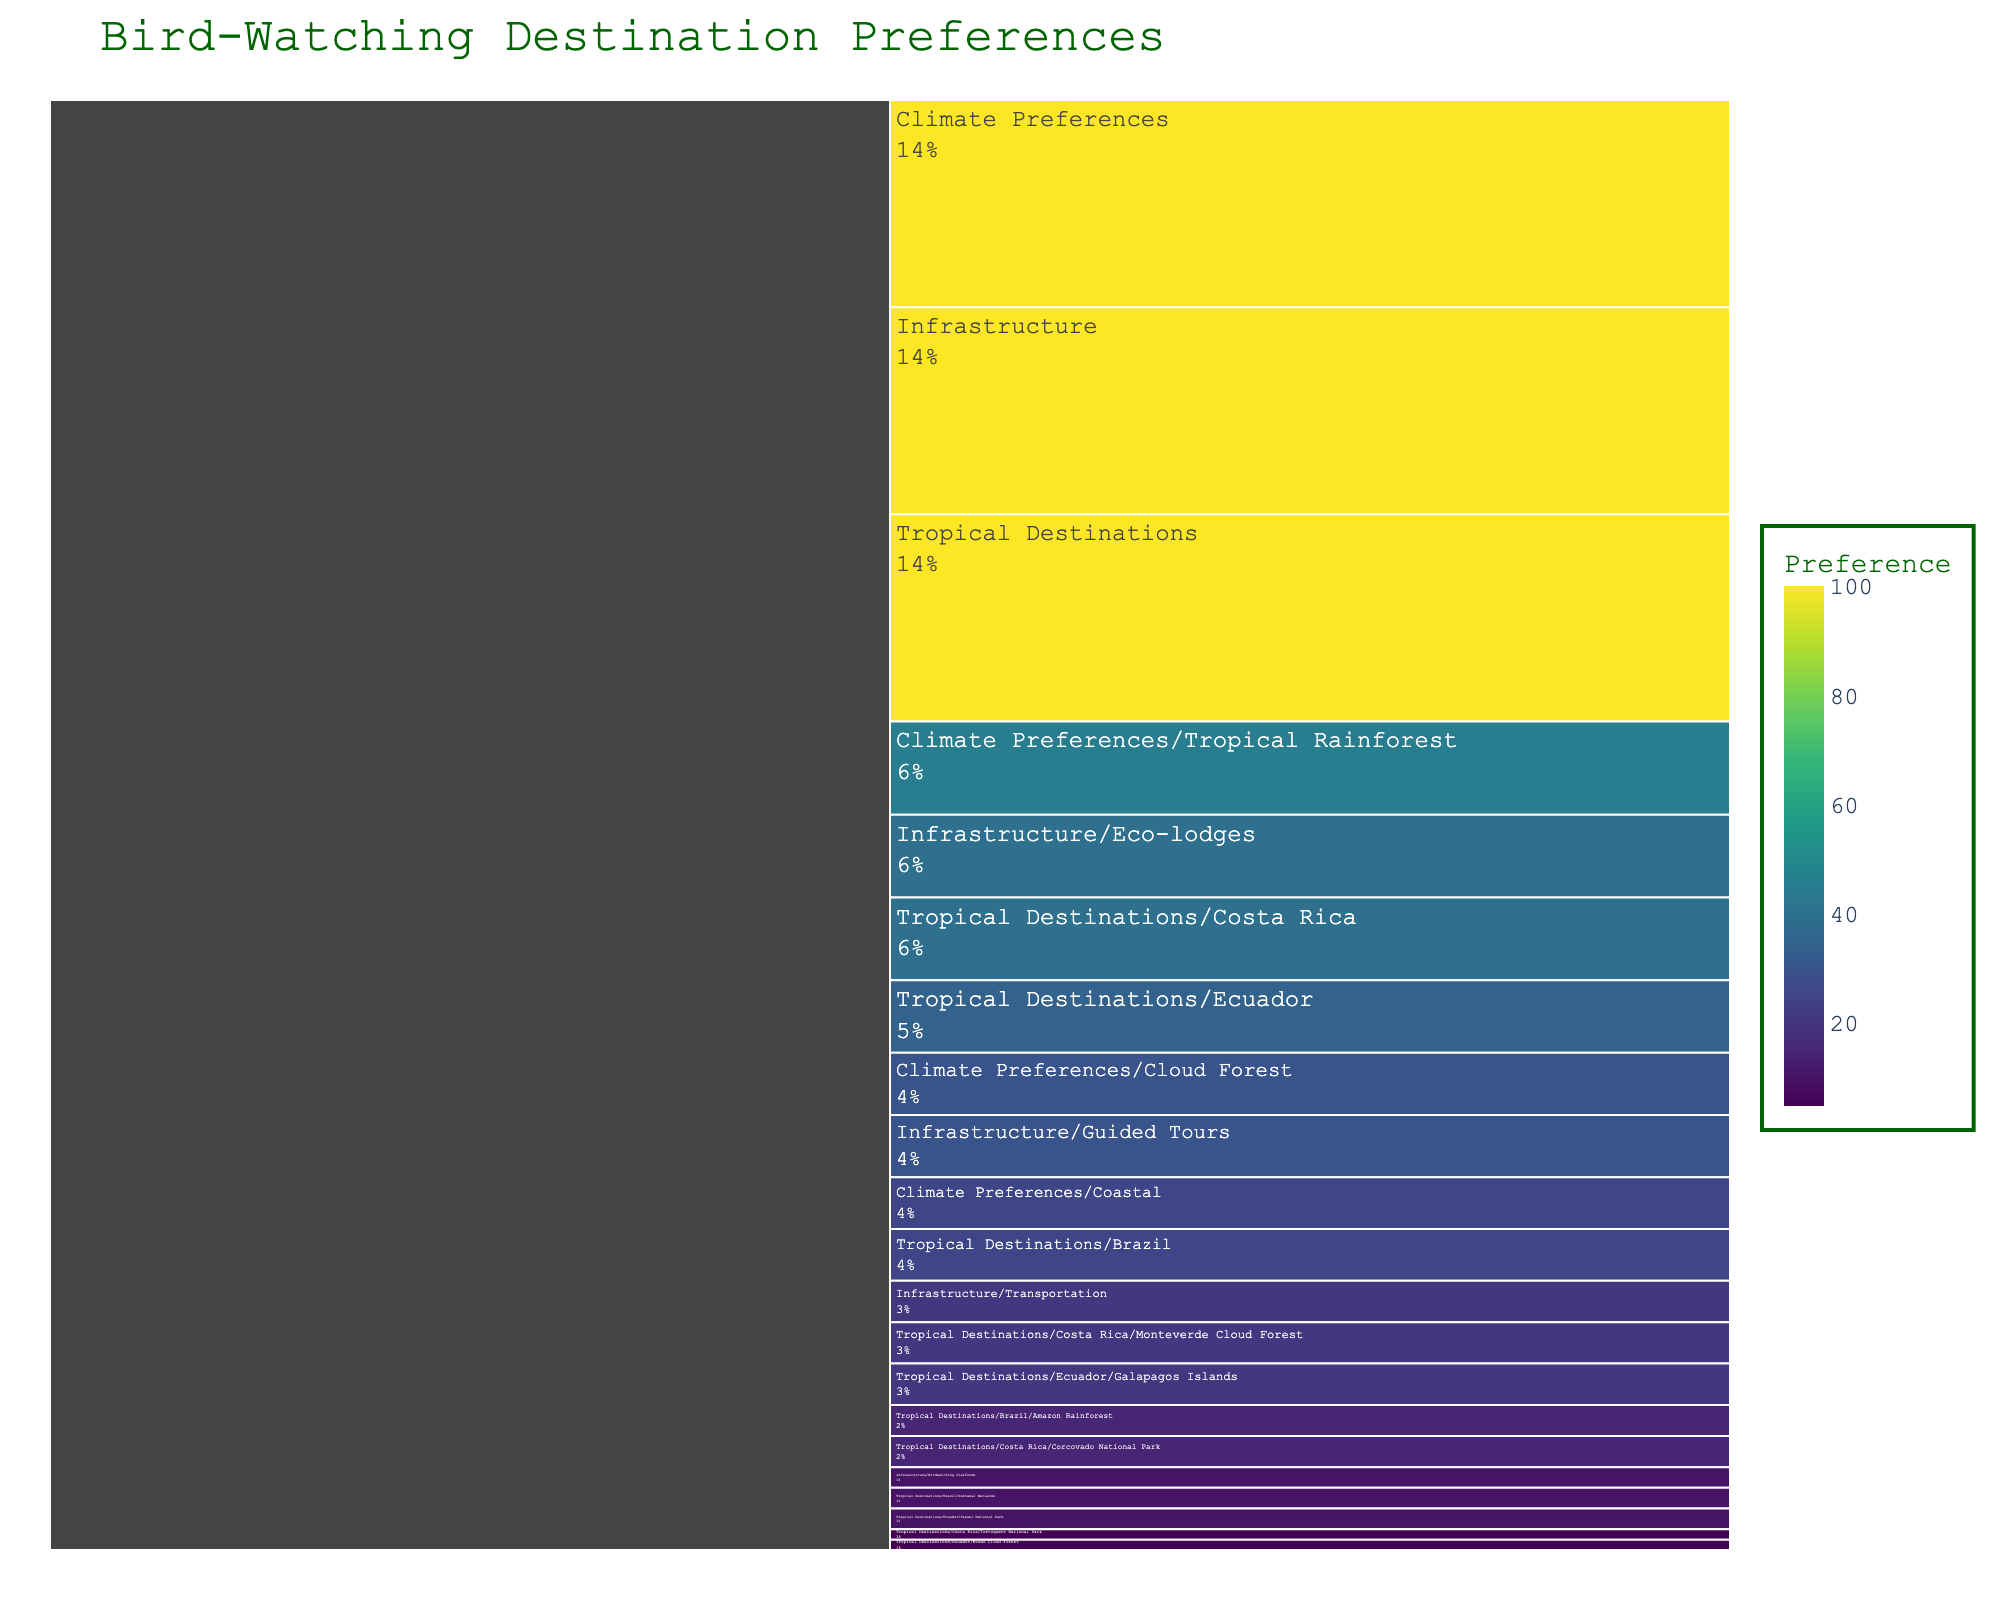What is the total preference percentage for Costa Rica within Tropical Destinations? We look at the preference values for Monteverde Cloud Forest (20), Corcovado National Park (15), and Tortuguero National Park (5). Summing them gives us 20 + 15 + 5 = 40. Therefore, the total preference percentage for Costa Rica is 40%.
Answer: 40% Which subcategory within Ecuador has the highest preference? We examine the subcategories under Ecuador and compare their preference values: Galapagos Islands (20), Yasuni National Park (10), and Mindo Cloud Forest (5). The highest preference is for Galapagos Islands.
Answer: Galapagos Islands How much higher is the preference for Tropical Rainforest compared to Coastal climate? The preference for Tropical Rainforest is 45, and for Coastal it is 25. The difference is 45 - 25 = 20.
Answer: 20 Which type of infrastructure has the lowest preference? We look at the preference values for all infrastructure types: Eco-lodges (40), Guided Tours (30), Transportation (20), and Birdwatching Platforms (10). The lowest preference is for Birdwatching Platforms.
Answer: Birdwatching Platforms What percentage of the total preference is given to the Galapagos Islands? Galapagos Islands have a preference value of 20 out of the total preference considered, which is 100 for Tropical Destinations. Therefore, the percentage is (20/100)*100% = 20%.
Answer: 20% Compare the total preferences for each country within Tropical Destinations. Which country has the highest total preference? Costa Rica (40), Ecuador (35), and Brazil (25). Costa Rica has the highest total preference.
Answer: Costa Rica What is the combined preference for Eco-lodges and Guided Tours? The values are Eco-lodges (40) and Guided Tours (30). The combined preference is 40 + 30 = 70.
Answer: 70 Between Monteverde Cloud Forest in Costa Rica and Amazon Rainforest in Brazil, which has a higher preference? The values are Monteverde Cloud Forest (20) and Amazon Rainforest (15). Monteverde Cloud Forest has a higher preference.
Answer: Monteverde Cloud Forest What is the sum of preferences for all Cloud Forest destinations? The relevant values are Monteverde Cloud Forest (20) and Mindo Cloud Forest (5). Summing them gives 20 + 5 = 25.
Answer: 25 Within preferences for infrastructure, how much higher is the preference for Eco-lodges compared to Transportation? Eco-lodges have a preference of 40, and Transportation has 20. The difference is 40 - 20 = 20.
Answer: 20 